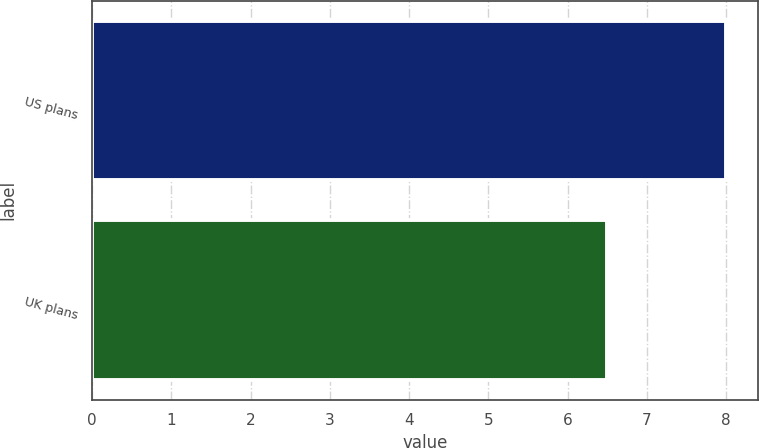<chart> <loc_0><loc_0><loc_500><loc_500><bar_chart><fcel>US plans<fcel>UK plans<nl><fcel>8<fcel>6.5<nl></chart> 